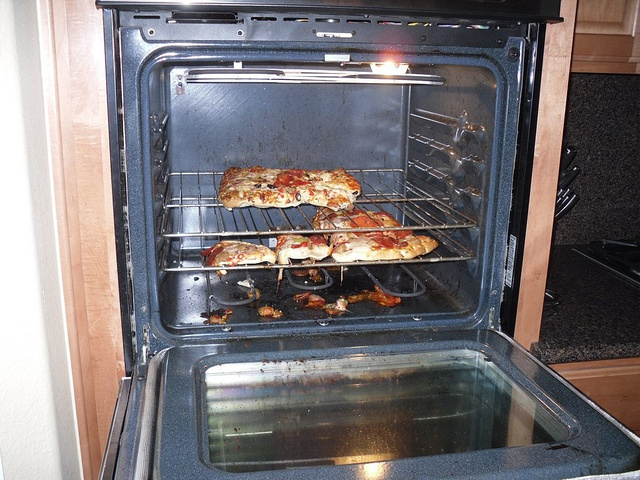Describe the objects in this image and their specific colors. I can see oven in lightgray, gray, black, and darkgray tones and pizza in lightgray, beige, tan, and brown tones in this image. 